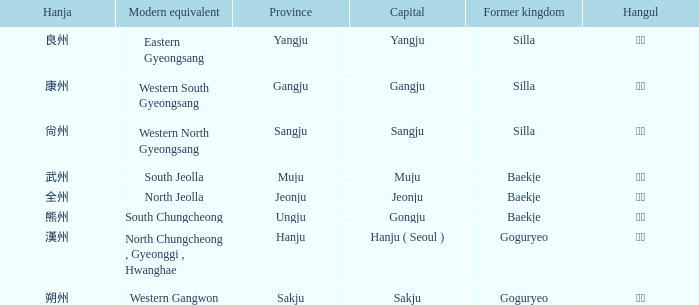The hanja 朔州 is for what province? Sakju. 